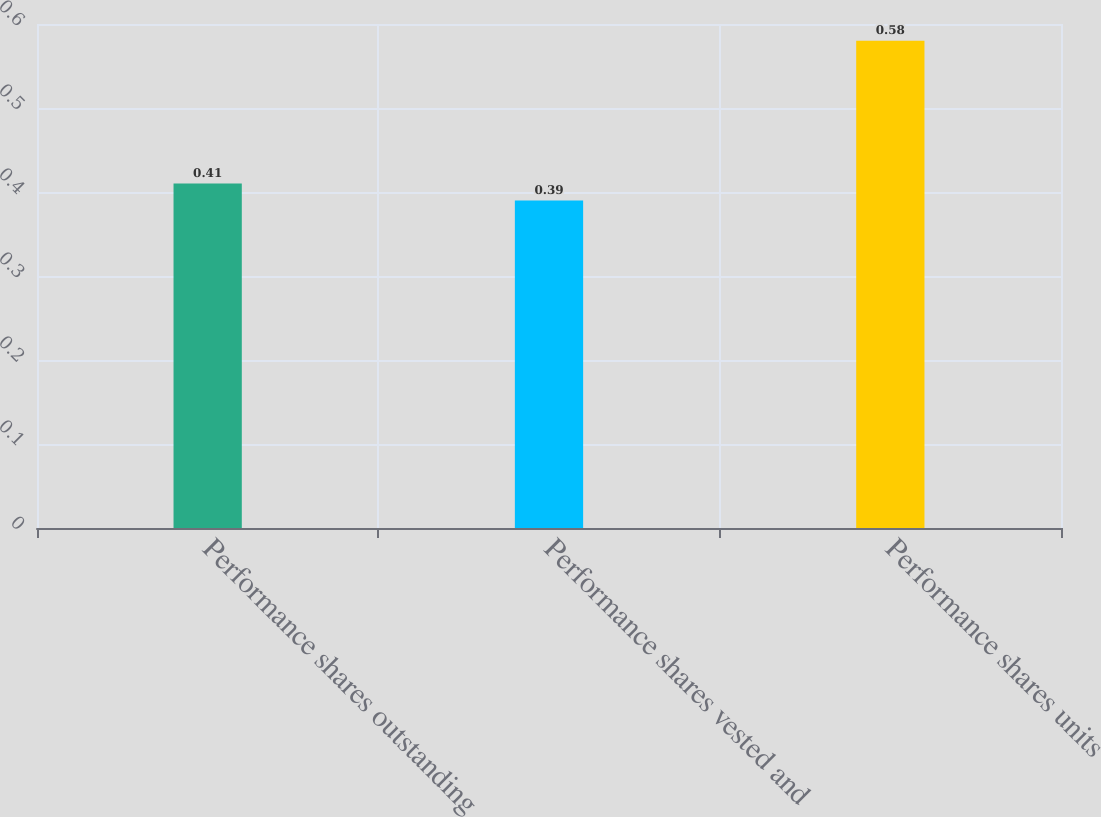Convert chart to OTSL. <chart><loc_0><loc_0><loc_500><loc_500><bar_chart><fcel>Performance shares outstanding<fcel>Performance shares vested and<fcel>Performance shares units<nl><fcel>0.41<fcel>0.39<fcel>0.58<nl></chart> 